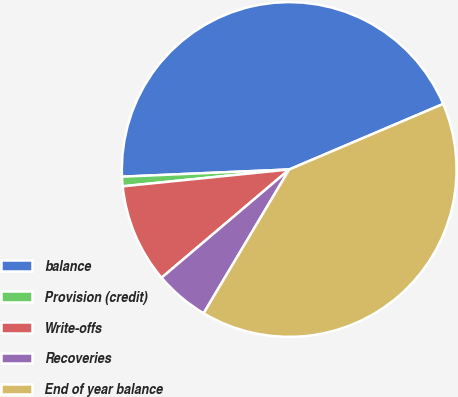<chart> <loc_0><loc_0><loc_500><loc_500><pie_chart><fcel>balance<fcel>Provision (credit)<fcel>Write-offs<fcel>Recoveries<fcel>End of year balance<nl><fcel>44.28%<fcel>0.92%<fcel>9.59%<fcel>5.26%<fcel>39.95%<nl></chart> 